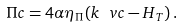<formula> <loc_0><loc_0><loc_500><loc_500>\Pi c = 4 \alpha \eta _ { \Pi } ( k \ v c - H _ { T } ) \, .</formula> 